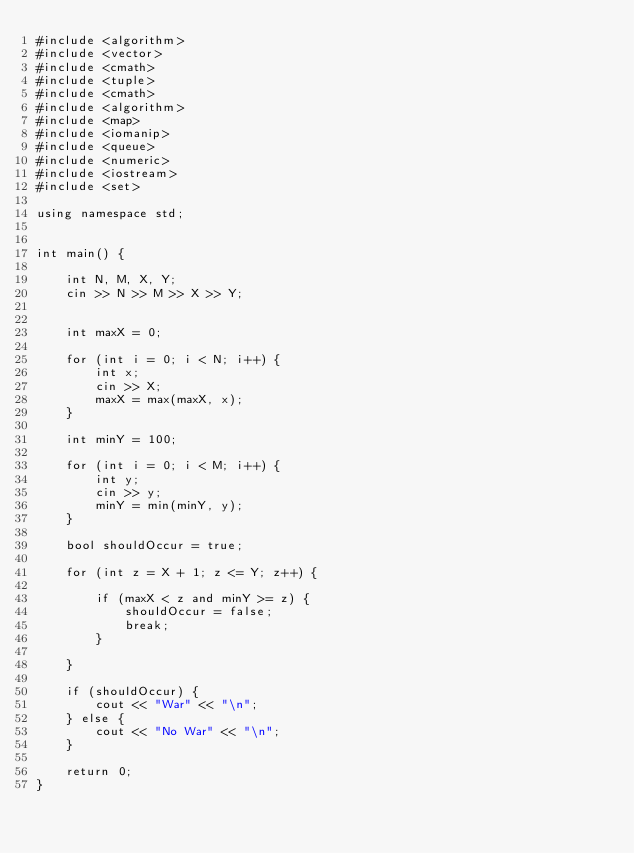<code> <loc_0><loc_0><loc_500><loc_500><_C++_>#include <algorithm>
#include <vector>
#include <cmath>
#include <tuple>
#include <cmath>
#include <algorithm>
#include <map>
#include <iomanip>
#include <queue>
#include <numeric>
#include <iostream>
#include <set>

using namespace std;


int main() {

    int N, M, X, Y;
    cin >> N >> M >> X >> Y;


    int maxX = 0;

    for (int i = 0; i < N; i++) {
        int x;
        cin >> X;
        maxX = max(maxX, x);
    }

    int minY = 100;

    for (int i = 0; i < M; i++) {
        int y;
        cin >> y;
        minY = min(minY, y);
    }

    bool shouldOccur = true;

    for (int z = X + 1; z <= Y; z++) {

        if (maxX < z and minY >= z) {
            shouldOccur = false;
            break;
        }

    }

    if (shouldOccur) {
        cout << "War" << "\n";
    } else {
        cout << "No War" << "\n";
    }

    return 0;
}</code> 